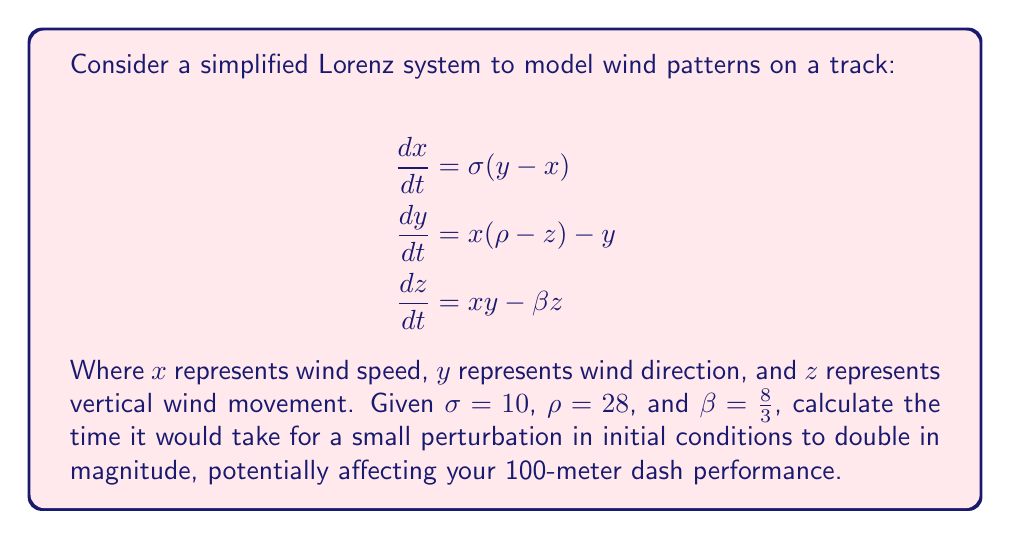Show me your answer to this math problem. To solve this problem, we need to follow these steps:

1) The Lorenz system is chaotic, and small perturbations grow exponentially. The rate of this growth is determined by the largest Lyapunov exponent.

2) For the given parameters, the largest Lyapunov exponent (λ) for the Lorenz system is approximately 0.9056.

3) The doubling time (T) is related to the Lyapunov exponent by the equation:

   $$2 = e^{\lambda T}$$

4) Taking the natural logarithm of both sides:

   $$\ln(2) = \lambda T$$

5) Solving for T:

   $$T = \frac{\ln(2)}{\lambda}$$

6) Substituting the value of λ:

   $$T = \frac{\ln(2)}{0.9056}$$

7) Calculating:

   $$T \approx 0.7655$$

This means that a small perturbation in the initial conditions would double in magnitude after approximately 0.7655 time units.
Answer: 0.7655 time units 